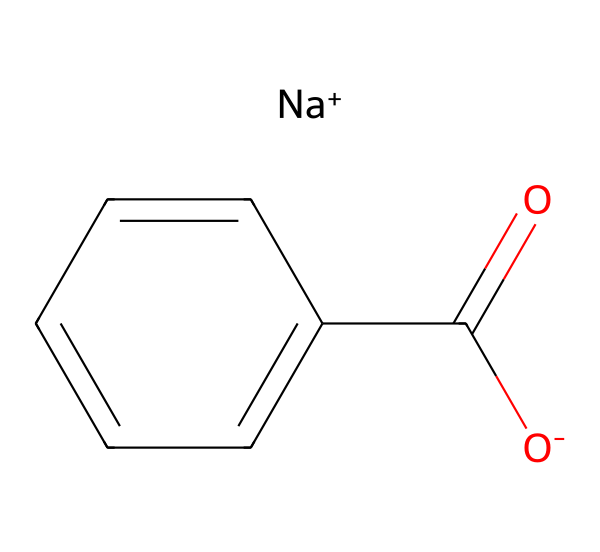What is the name of this chemical? The SMILES notation shows the structure and gives clues to identify the chemical. The part that identifies the compound is "c1ccccc1," which indicates a benzene ring. Thus, the full structure corresponds to sodium benzoate.
Answer: sodium benzoate How many carbon atoms are present in this molecule? In the given SMILES, "C(=O)" represents one carbon, and the benzene structure "c1ccccc1" contains six carbon atoms. Adding both gives a total of seven carbon atoms.
Answer: 7 What type of chemical is sodium benzoate? Sodium benzoate is classified as a preservative, which is often used in food and drink products to prevent spoilage. This classification comes from its structure and intended use.
Answer: preservative What functional group is present in sodium benzoate? The molecule contains the carboxylate (-COO-) functional group, which is indicated by the "C(=O)" and the connected oxygen atom "O-." This specific structure is characteristic of carboxylic acids and their salts.
Answer: carboxylate How many hydrogen atoms are in sodium benzoate? In the molecular structure, each carbon in the benzene ring typically bonds with one hydrogen. There are six hydrogens from the benzene ring, plus the additional hydrogen from the carboxylic group before sodium replaces it. Hence, there are five hydrogen atoms in total.
Answer: 5 Why is sodium benzoate used in energy drinks? Sodium benzoate is effective in preventing the growth of bacteria, yeast, and fungi, which helps preserve the energy drinks for a longer period. Its presence in the chemical structure indicates its role as a safe preservative.
Answer: preservation 